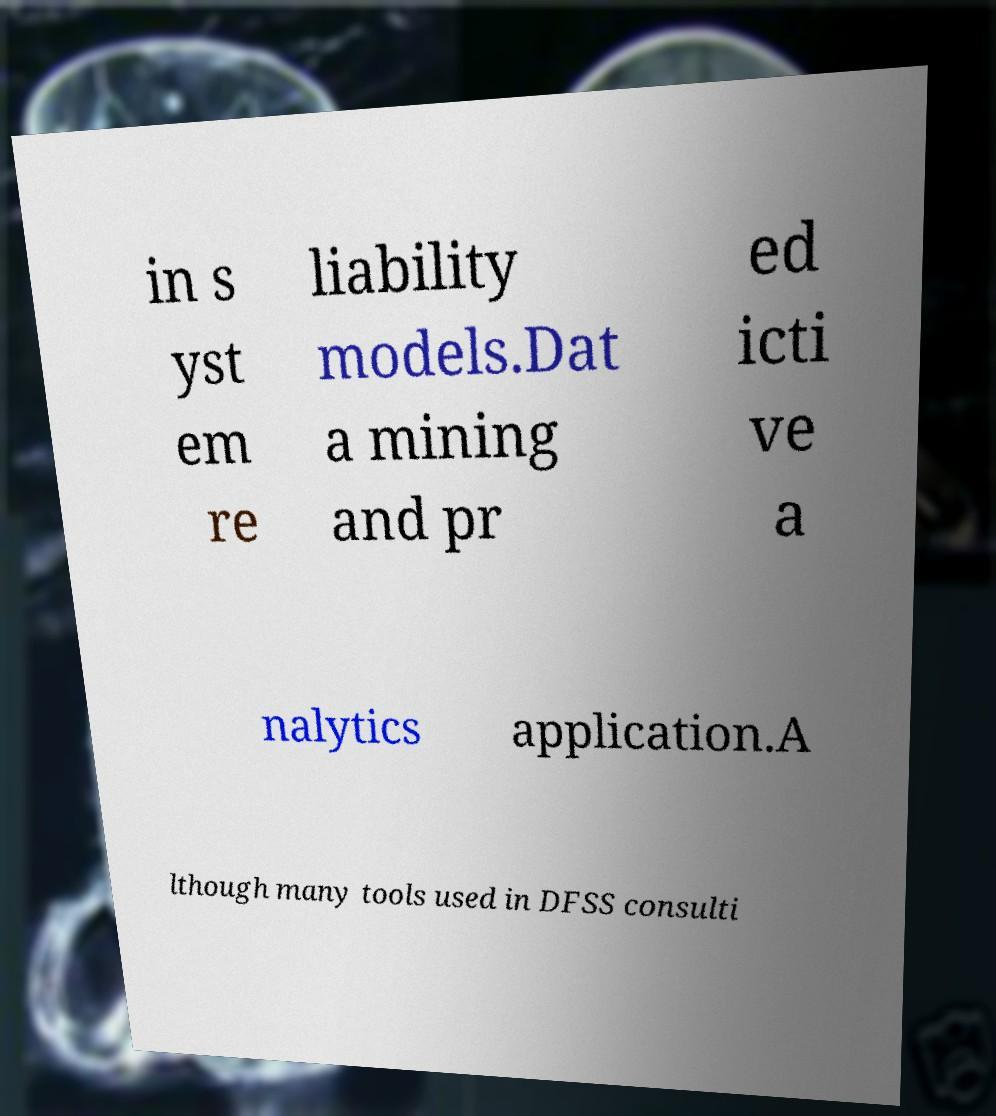What messages or text are displayed in this image? I need them in a readable, typed format. in s yst em re liability models.Dat a mining and pr ed icti ve a nalytics application.A lthough many tools used in DFSS consulti 